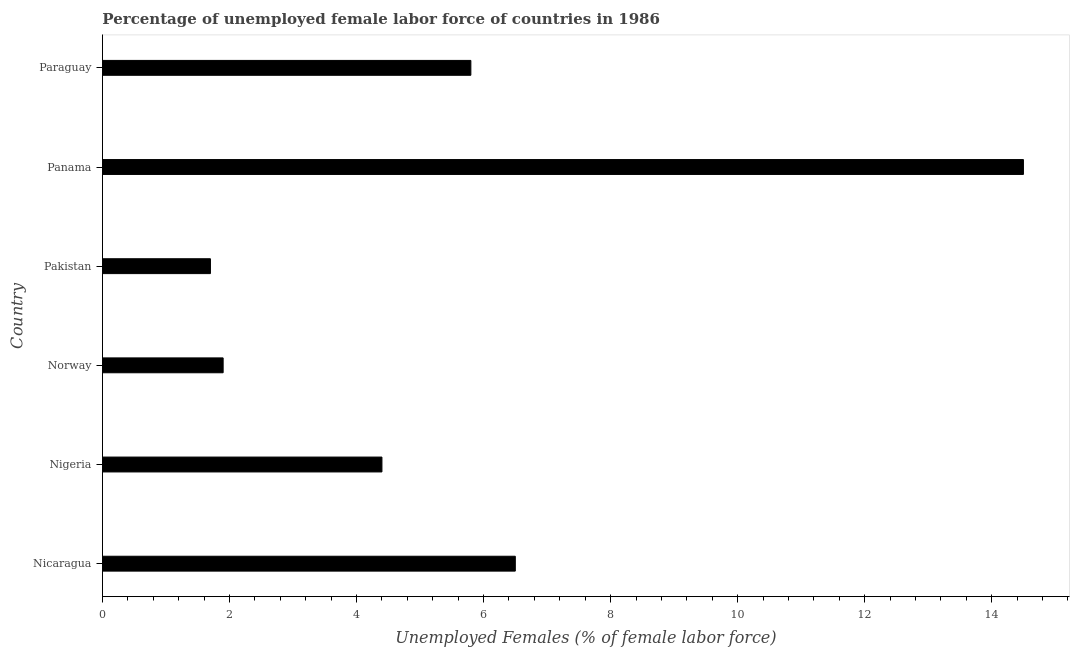Does the graph contain any zero values?
Give a very brief answer. No. Does the graph contain grids?
Ensure brevity in your answer.  No. What is the title of the graph?
Provide a short and direct response. Percentage of unemployed female labor force of countries in 1986. What is the label or title of the X-axis?
Provide a short and direct response. Unemployed Females (% of female labor force). Across all countries, what is the minimum total unemployed female labour force?
Your answer should be compact. 1.7. In which country was the total unemployed female labour force maximum?
Keep it short and to the point. Panama. In which country was the total unemployed female labour force minimum?
Offer a very short reply. Pakistan. What is the sum of the total unemployed female labour force?
Your response must be concise. 34.8. What is the median total unemployed female labour force?
Your response must be concise. 5.1. In how many countries, is the total unemployed female labour force greater than 9.6 %?
Make the answer very short. 1. What is the ratio of the total unemployed female labour force in Nicaragua to that in Nigeria?
Provide a succinct answer. 1.48. Is the difference between the total unemployed female labour force in Norway and Panama greater than the difference between any two countries?
Ensure brevity in your answer.  No. What is the Unemployed Females (% of female labor force) in Nicaragua?
Offer a very short reply. 6.5. What is the Unemployed Females (% of female labor force) of Nigeria?
Your answer should be very brief. 4.4. What is the Unemployed Females (% of female labor force) in Norway?
Provide a short and direct response. 1.9. What is the Unemployed Females (% of female labor force) in Pakistan?
Provide a succinct answer. 1.7. What is the Unemployed Females (% of female labor force) in Paraguay?
Your answer should be very brief. 5.8. What is the difference between the Unemployed Females (% of female labor force) in Nicaragua and Norway?
Offer a terse response. 4.6. What is the difference between the Unemployed Females (% of female labor force) in Nigeria and Pakistan?
Offer a terse response. 2.7. What is the difference between the Unemployed Females (% of female labor force) in Nigeria and Paraguay?
Ensure brevity in your answer.  -1.4. What is the difference between the Unemployed Females (% of female labor force) in Norway and Pakistan?
Keep it short and to the point. 0.2. What is the difference between the Unemployed Females (% of female labor force) in Norway and Paraguay?
Your answer should be very brief. -3.9. What is the difference between the Unemployed Females (% of female labor force) in Pakistan and Paraguay?
Your response must be concise. -4.1. What is the ratio of the Unemployed Females (% of female labor force) in Nicaragua to that in Nigeria?
Offer a very short reply. 1.48. What is the ratio of the Unemployed Females (% of female labor force) in Nicaragua to that in Norway?
Give a very brief answer. 3.42. What is the ratio of the Unemployed Females (% of female labor force) in Nicaragua to that in Pakistan?
Offer a terse response. 3.82. What is the ratio of the Unemployed Females (% of female labor force) in Nicaragua to that in Panama?
Keep it short and to the point. 0.45. What is the ratio of the Unemployed Females (% of female labor force) in Nicaragua to that in Paraguay?
Keep it short and to the point. 1.12. What is the ratio of the Unemployed Females (% of female labor force) in Nigeria to that in Norway?
Give a very brief answer. 2.32. What is the ratio of the Unemployed Females (% of female labor force) in Nigeria to that in Pakistan?
Ensure brevity in your answer.  2.59. What is the ratio of the Unemployed Females (% of female labor force) in Nigeria to that in Panama?
Keep it short and to the point. 0.3. What is the ratio of the Unemployed Females (% of female labor force) in Nigeria to that in Paraguay?
Offer a very short reply. 0.76. What is the ratio of the Unemployed Females (% of female labor force) in Norway to that in Pakistan?
Provide a succinct answer. 1.12. What is the ratio of the Unemployed Females (% of female labor force) in Norway to that in Panama?
Ensure brevity in your answer.  0.13. What is the ratio of the Unemployed Females (% of female labor force) in Norway to that in Paraguay?
Give a very brief answer. 0.33. What is the ratio of the Unemployed Females (% of female labor force) in Pakistan to that in Panama?
Provide a succinct answer. 0.12. What is the ratio of the Unemployed Females (% of female labor force) in Pakistan to that in Paraguay?
Provide a short and direct response. 0.29. 